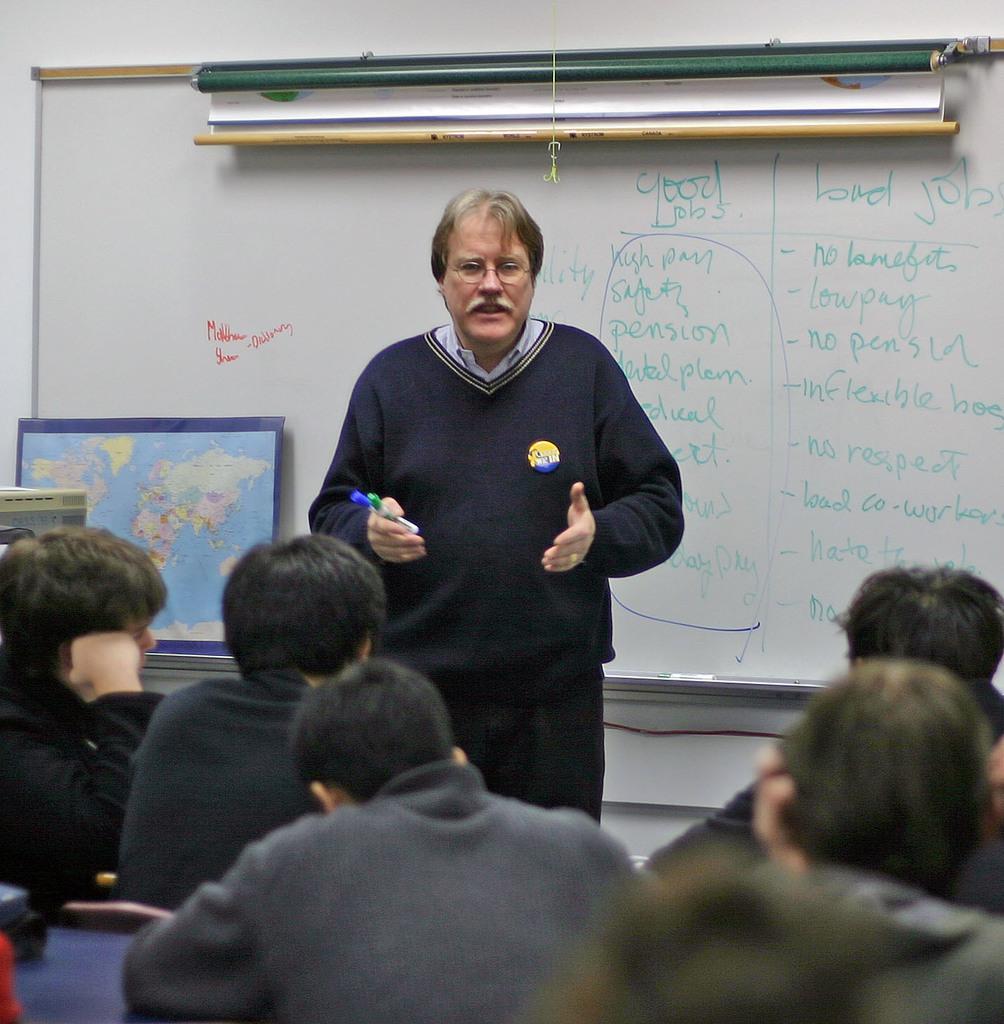Please provide a concise description of this image. This picture is clicked inside the room. The man in the middle of the picture who is wearing a black sweater is holding markers in his hand and I think he is explaining something. Behind him, we see a chart and a white board with some text written on it. Behind that, we see a wall. On the left side, we see the chart of the world map. At the bottom of the picture, we see people are sitting on the chairs or benches and they are listening to him. 